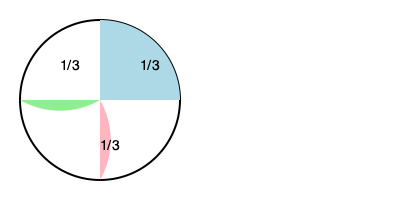You're preparing a homemade casserole for your children's dinner. The recipe makes 6 servings, but you only need 4 servings tonight. If you divide the casserole into thirds as shown in the fraction circle, how many thirds should you serve to your children to provide 4 servings? Let's approach this step-by-step:

1) The full recipe makes 6 servings.
2) We need 4 servings.
3) The casserole is divided into thirds (3 equal parts).

To find how many thirds we need for 4 servings:

4) First, let's find what fraction of the whole casserole 4 servings represent:
   $\frac{4 \text{ servings needed}}{6 \text{ total servings}} = \frac{2}{3}$ of the whole casserole

5) Now, we need to convert $\frac{2}{3}$ of the whole into the number of thirds:
   
   $\frac{2}{3} \times 3 \text{ thirds} = 2 \text{ thirds}$

Therefore, you should serve 2 thirds of the casserole to provide 4 servings.
Answer: 2 thirds 